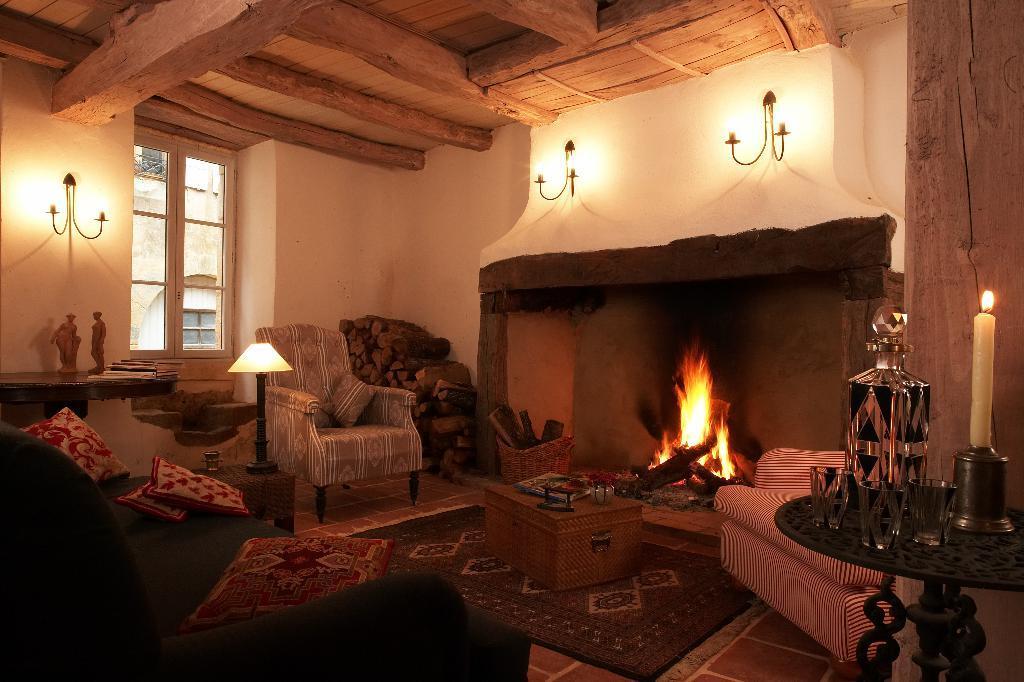Can you describe this image briefly? In this image we can see inside view of a room, in which we can see some chairs and some wood logs placed on the ground, we can also see a lamp and some objects placed on tables. On the right side of the image we can see a candle, some glasses and a bottle placed on the table. On the left side of the image we can see statues and books. In the background, we can see some lights on the wall and window. 